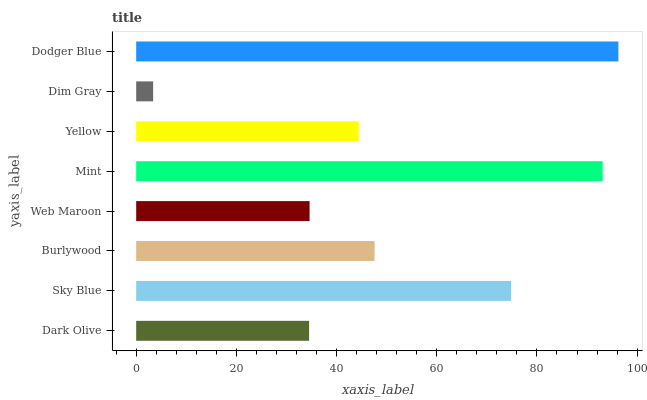Is Dim Gray the minimum?
Answer yes or no. Yes. Is Dodger Blue the maximum?
Answer yes or no. Yes. Is Sky Blue the minimum?
Answer yes or no. No. Is Sky Blue the maximum?
Answer yes or no. No. Is Sky Blue greater than Dark Olive?
Answer yes or no. Yes. Is Dark Olive less than Sky Blue?
Answer yes or no. Yes. Is Dark Olive greater than Sky Blue?
Answer yes or no. No. Is Sky Blue less than Dark Olive?
Answer yes or no. No. Is Burlywood the high median?
Answer yes or no. Yes. Is Yellow the low median?
Answer yes or no. Yes. Is Mint the high median?
Answer yes or no. No. Is Web Maroon the low median?
Answer yes or no. No. 